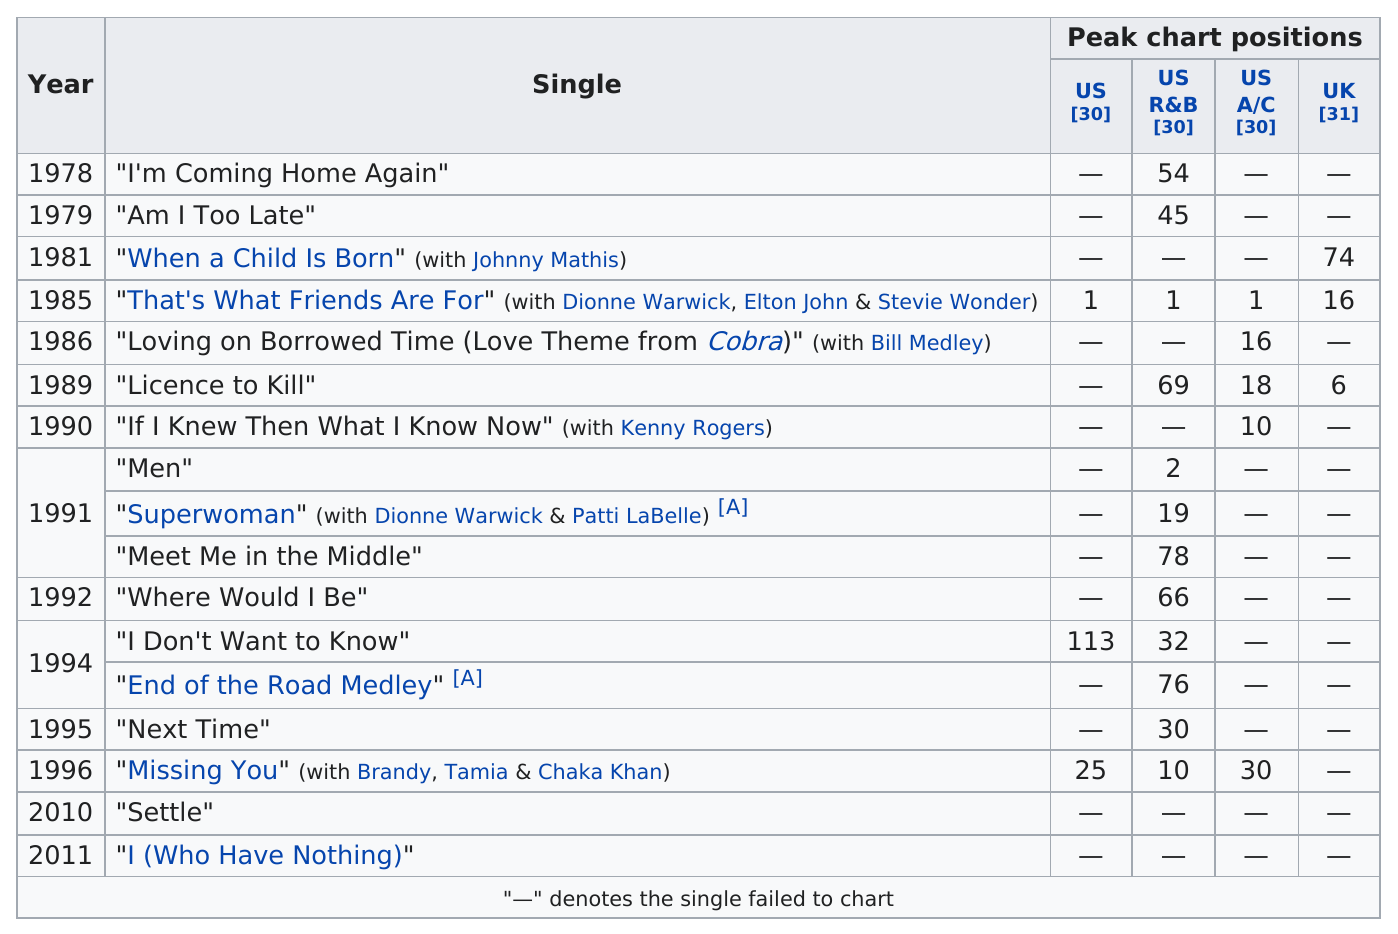Specify some key components in this picture. The single "Am I Too Late?" was released in 1979. The song titled "Men" ranked as the second position on the US R&B chart. In the year 1991, the single "Superwoman" was released. 